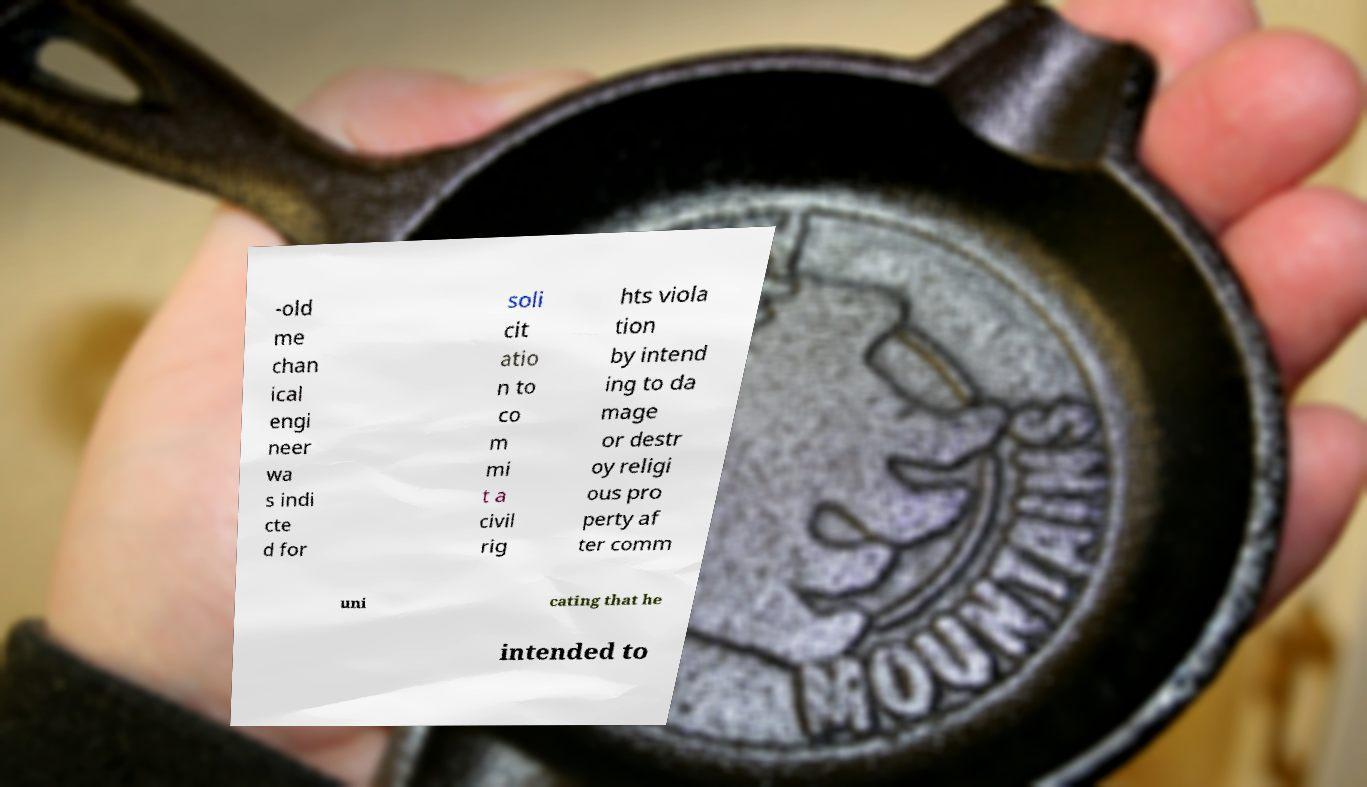For documentation purposes, I need the text within this image transcribed. Could you provide that? -old me chan ical engi neer wa s indi cte d for soli cit atio n to co m mi t a civil rig hts viola tion by intend ing to da mage or destr oy religi ous pro perty af ter comm uni cating that he intended to 